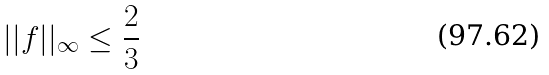<formula> <loc_0><loc_0><loc_500><loc_500>| | f | | _ { \infty } \leq \frac { 2 } { 3 }</formula> 